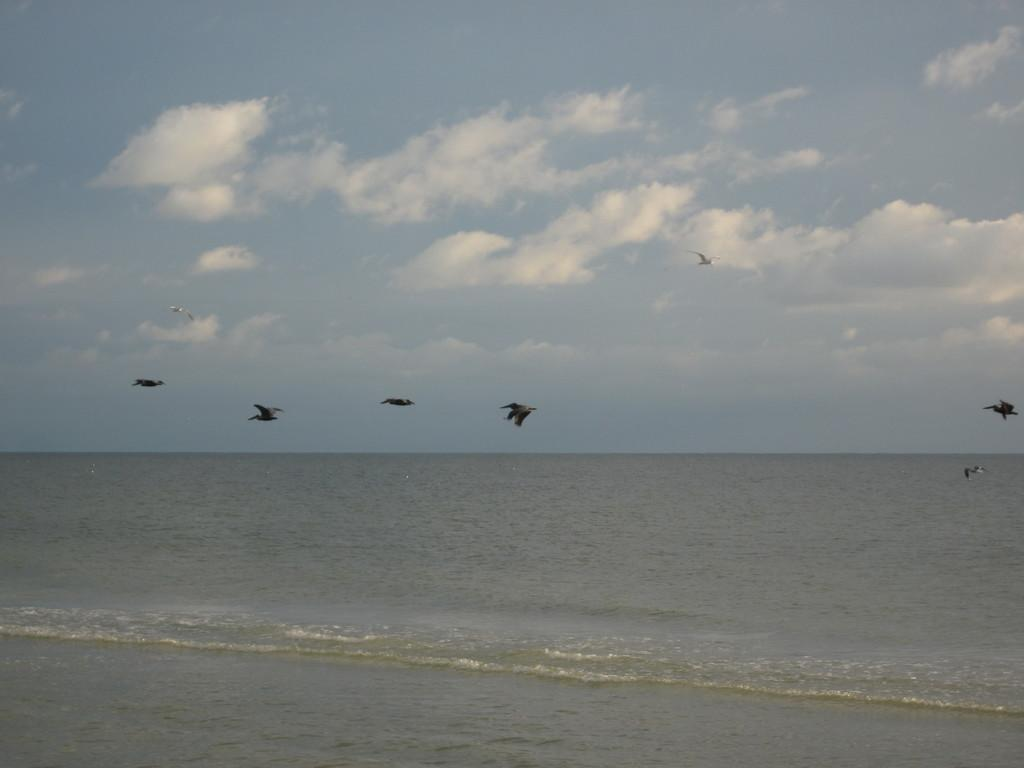What is happening in the sky in the image? There are birds flying in the air in the image. What can be seen below the birds in the image? There is water visible in the image. What else is visible in the image besides the birds and water? The sky is visible in the image. What type of wall can be seen in the image? There is no wall present in the image; it features birds flying in the air and water below. 